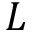Convert formula to latex. <formula><loc_0><loc_0><loc_500><loc_500>L</formula> 